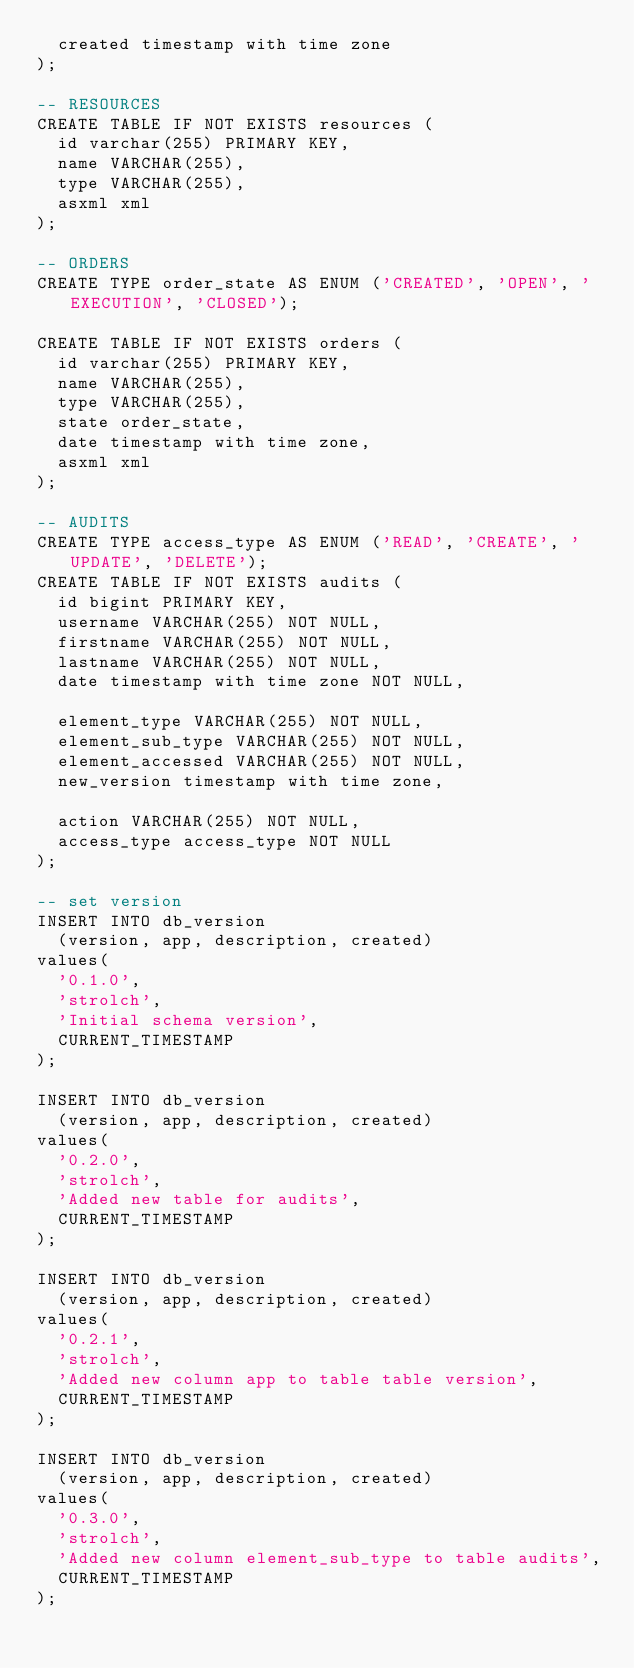Convert code to text. <code><loc_0><loc_0><loc_500><loc_500><_SQL_>  created timestamp with time zone
);

-- RESOURCES
CREATE TABLE IF NOT EXISTS resources (
  id varchar(255) PRIMARY KEY, 
  name VARCHAR(255),
  type VARCHAR(255),
  asxml xml
);

-- ORDERS
CREATE TYPE order_state AS ENUM ('CREATED', 'OPEN', 'EXECUTION', 'CLOSED');

CREATE TABLE IF NOT EXISTS orders (
  id varchar(255) PRIMARY KEY, 
  name VARCHAR(255),
  type VARCHAR(255),
  state order_state,
  date timestamp with time zone,
  asxml xml
);

-- AUDITS
CREATE TYPE access_type AS ENUM ('READ', 'CREATE', 'UPDATE', 'DELETE');
CREATE TABLE IF NOT EXISTS audits (
  id bigint PRIMARY KEY,
  username VARCHAR(255) NOT NULL,
  firstname VARCHAR(255) NOT NULL,
  lastname VARCHAR(255) NOT NULL,
  date timestamp with time zone NOT NULL,

  element_type VARCHAR(255) NOT NULL,
  element_sub_type VARCHAR(255) NOT NULL,
  element_accessed VARCHAR(255) NOT NULL,
  new_version timestamp with time zone,

  action VARCHAR(255) NOT NULL,
  access_type access_type NOT NULL
);

-- set version
INSERT INTO db_version 
  (version, app, description, created) 
values(
  '0.1.0',
  'strolch',
  'Initial schema version',
  CURRENT_TIMESTAMP
);

INSERT INTO db_version 
  (version, app, description, created) 
values(
  '0.2.0',
  'strolch',
  'Added new table for audits',
  CURRENT_TIMESTAMP
);

INSERT INTO db_version 
  (version, app, description, created) 
values(
  '0.2.1',
  'strolch',
  'Added new column app to table table version',
  CURRENT_TIMESTAMP
);

INSERT INTO db_version 
  (version, app, description, created) 
values(
  '0.3.0',
  'strolch',
  'Added new column element_sub_type to table audits',
  CURRENT_TIMESTAMP
);
</code> 